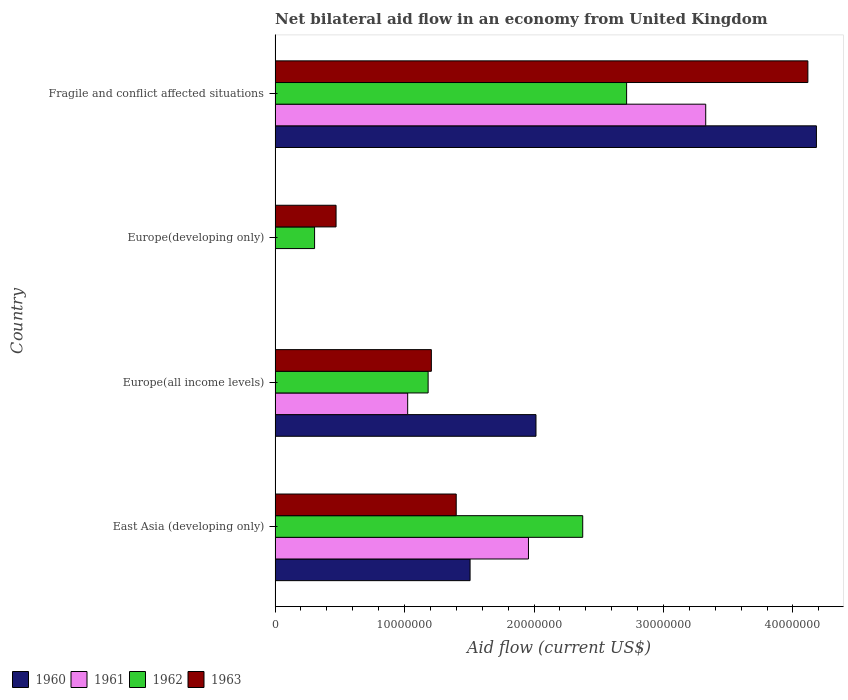How many different coloured bars are there?
Your answer should be compact. 4. How many bars are there on the 1st tick from the bottom?
Keep it short and to the point. 4. What is the label of the 1st group of bars from the top?
Ensure brevity in your answer.  Fragile and conflict affected situations. In how many cases, is the number of bars for a given country not equal to the number of legend labels?
Your response must be concise. 1. What is the net bilateral aid flow in 1962 in Europe(developing only)?
Keep it short and to the point. 3.05e+06. Across all countries, what is the maximum net bilateral aid flow in 1962?
Offer a very short reply. 2.72e+07. Across all countries, what is the minimum net bilateral aid flow in 1963?
Give a very brief answer. 4.71e+06. In which country was the net bilateral aid flow in 1961 maximum?
Make the answer very short. Fragile and conflict affected situations. What is the total net bilateral aid flow in 1962 in the graph?
Your answer should be compact. 6.58e+07. What is the difference between the net bilateral aid flow in 1963 in East Asia (developing only) and that in Fragile and conflict affected situations?
Your answer should be compact. -2.72e+07. What is the difference between the net bilateral aid flow in 1960 in Europe(developing only) and the net bilateral aid flow in 1961 in Europe(all income levels)?
Offer a terse response. -1.02e+07. What is the average net bilateral aid flow in 1962 per country?
Provide a succinct answer. 1.64e+07. What is the difference between the net bilateral aid flow in 1963 and net bilateral aid flow in 1961 in East Asia (developing only)?
Your answer should be compact. -5.58e+06. In how many countries, is the net bilateral aid flow in 1961 greater than 10000000 US$?
Offer a very short reply. 3. What is the ratio of the net bilateral aid flow in 1962 in East Asia (developing only) to that in Europe(all income levels)?
Offer a very short reply. 2.01. Is the net bilateral aid flow in 1963 in East Asia (developing only) less than that in Fragile and conflict affected situations?
Keep it short and to the point. Yes. What is the difference between the highest and the second highest net bilateral aid flow in 1962?
Make the answer very short. 3.39e+06. What is the difference between the highest and the lowest net bilateral aid flow in 1963?
Ensure brevity in your answer.  3.64e+07. Is the sum of the net bilateral aid flow in 1962 in East Asia (developing only) and Europe(all income levels) greater than the maximum net bilateral aid flow in 1963 across all countries?
Ensure brevity in your answer.  No. Is it the case that in every country, the sum of the net bilateral aid flow in 1960 and net bilateral aid flow in 1963 is greater than the sum of net bilateral aid flow in 1962 and net bilateral aid flow in 1961?
Provide a succinct answer. No. Is it the case that in every country, the sum of the net bilateral aid flow in 1963 and net bilateral aid flow in 1960 is greater than the net bilateral aid flow in 1962?
Your response must be concise. Yes. How many countries are there in the graph?
Keep it short and to the point. 4. What is the title of the graph?
Offer a very short reply. Net bilateral aid flow in an economy from United Kingdom. Does "1964" appear as one of the legend labels in the graph?
Offer a terse response. No. What is the Aid flow (current US$) in 1960 in East Asia (developing only)?
Keep it short and to the point. 1.51e+07. What is the Aid flow (current US$) in 1961 in East Asia (developing only)?
Your answer should be compact. 1.96e+07. What is the Aid flow (current US$) of 1962 in East Asia (developing only)?
Your answer should be compact. 2.38e+07. What is the Aid flow (current US$) of 1963 in East Asia (developing only)?
Give a very brief answer. 1.40e+07. What is the Aid flow (current US$) in 1960 in Europe(all income levels)?
Provide a succinct answer. 2.02e+07. What is the Aid flow (current US$) in 1961 in Europe(all income levels)?
Offer a very short reply. 1.02e+07. What is the Aid flow (current US$) of 1962 in Europe(all income levels)?
Make the answer very short. 1.18e+07. What is the Aid flow (current US$) in 1963 in Europe(all income levels)?
Make the answer very short. 1.21e+07. What is the Aid flow (current US$) in 1961 in Europe(developing only)?
Provide a succinct answer. 0. What is the Aid flow (current US$) of 1962 in Europe(developing only)?
Your answer should be very brief. 3.05e+06. What is the Aid flow (current US$) in 1963 in Europe(developing only)?
Keep it short and to the point. 4.71e+06. What is the Aid flow (current US$) of 1960 in Fragile and conflict affected situations?
Your answer should be compact. 4.18e+07. What is the Aid flow (current US$) in 1961 in Fragile and conflict affected situations?
Your answer should be very brief. 3.33e+07. What is the Aid flow (current US$) in 1962 in Fragile and conflict affected situations?
Your answer should be compact. 2.72e+07. What is the Aid flow (current US$) in 1963 in Fragile and conflict affected situations?
Your answer should be very brief. 4.12e+07. Across all countries, what is the maximum Aid flow (current US$) in 1960?
Give a very brief answer. 4.18e+07. Across all countries, what is the maximum Aid flow (current US$) of 1961?
Keep it short and to the point. 3.33e+07. Across all countries, what is the maximum Aid flow (current US$) in 1962?
Make the answer very short. 2.72e+07. Across all countries, what is the maximum Aid flow (current US$) of 1963?
Offer a very short reply. 4.12e+07. Across all countries, what is the minimum Aid flow (current US$) of 1962?
Provide a short and direct response. 3.05e+06. Across all countries, what is the minimum Aid flow (current US$) of 1963?
Your answer should be very brief. 4.71e+06. What is the total Aid flow (current US$) of 1960 in the graph?
Provide a succinct answer. 7.70e+07. What is the total Aid flow (current US$) in 1961 in the graph?
Your answer should be very brief. 6.31e+07. What is the total Aid flow (current US$) of 1962 in the graph?
Your answer should be compact. 6.58e+07. What is the total Aid flow (current US$) of 1963 in the graph?
Provide a short and direct response. 7.19e+07. What is the difference between the Aid flow (current US$) in 1960 in East Asia (developing only) and that in Europe(all income levels)?
Keep it short and to the point. -5.09e+06. What is the difference between the Aid flow (current US$) of 1961 in East Asia (developing only) and that in Europe(all income levels)?
Ensure brevity in your answer.  9.33e+06. What is the difference between the Aid flow (current US$) of 1962 in East Asia (developing only) and that in Europe(all income levels)?
Provide a short and direct response. 1.19e+07. What is the difference between the Aid flow (current US$) in 1963 in East Asia (developing only) and that in Europe(all income levels)?
Give a very brief answer. 1.92e+06. What is the difference between the Aid flow (current US$) in 1962 in East Asia (developing only) and that in Europe(developing only)?
Keep it short and to the point. 2.07e+07. What is the difference between the Aid flow (current US$) in 1963 in East Asia (developing only) and that in Europe(developing only)?
Give a very brief answer. 9.28e+06. What is the difference between the Aid flow (current US$) in 1960 in East Asia (developing only) and that in Fragile and conflict affected situations?
Provide a short and direct response. -2.68e+07. What is the difference between the Aid flow (current US$) of 1961 in East Asia (developing only) and that in Fragile and conflict affected situations?
Your response must be concise. -1.37e+07. What is the difference between the Aid flow (current US$) in 1962 in East Asia (developing only) and that in Fragile and conflict affected situations?
Provide a succinct answer. -3.39e+06. What is the difference between the Aid flow (current US$) of 1963 in East Asia (developing only) and that in Fragile and conflict affected situations?
Make the answer very short. -2.72e+07. What is the difference between the Aid flow (current US$) of 1962 in Europe(all income levels) and that in Europe(developing only)?
Your response must be concise. 8.77e+06. What is the difference between the Aid flow (current US$) of 1963 in Europe(all income levels) and that in Europe(developing only)?
Your answer should be very brief. 7.36e+06. What is the difference between the Aid flow (current US$) of 1960 in Europe(all income levels) and that in Fragile and conflict affected situations?
Ensure brevity in your answer.  -2.17e+07. What is the difference between the Aid flow (current US$) of 1961 in Europe(all income levels) and that in Fragile and conflict affected situations?
Provide a short and direct response. -2.30e+07. What is the difference between the Aid flow (current US$) of 1962 in Europe(all income levels) and that in Fragile and conflict affected situations?
Give a very brief answer. -1.53e+07. What is the difference between the Aid flow (current US$) in 1963 in Europe(all income levels) and that in Fragile and conflict affected situations?
Make the answer very short. -2.91e+07. What is the difference between the Aid flow (current US$) of 1962 in Europe(developing only) and that in Fragile and conflict affected situations?
Ensure brevity in your answer.  -2.41e+07. What is the difference between the Aid flow (current US$) of 1963 in Europe(developing only) and that in Fragile and conflict affected situations?
Provide a short and direct response. -3.64e+07. What is the difference between the Aid flow (current US$) of 1960 in East Asia (developing only) and the Aid flow (current US$) of 1961 in Europe(all income levels)?
Give a very brief answer. 4.82e+06. What is the difference between the Aid flow (current US$) in 1960 in East Asia (developing only) and the Aid flow (current US$) in 1962 in Europe(all income levels)?
Offer a terse response. 3.24e+06. What is the difference between the Aid flow (current US$) in 1960 in East Asia (developing only) and the Aid flow (current US$) in 1963 in Europe(all income levels)?
Give a very brief answer. 2.99e+06. What is the difference between the Aid flow (current US$) in 1961 in East Asia (developing only) and the Aid flow (current US$) in 1962 in Europe(all income levels)?
Provide a short and direct response. 7.75e+06. What is the difference between the Aid flow (current US$) in 1961 in East Asia (developing only) and the Aid flow (current US$) in 1963 in Europe(all income levels)?
Offer a very short reply. 7.50e+06. What is the difference between the Aid flow (current US$) in 1962 in East Asia (developing only) and the Aid flow (current US$) in 1963 in Europe(all income levels)?
Provide a short and direct response. 1.17e+07. What is the difference between the Aid flow (current US$) of 1960 in East Asia (developing only) and the Aid flow (current US$) of 1962 in Europe(developing only)?
Give a very brief answer. 1.20e+07. What is the difference between the Aid flow (current US$) in 1960 in East Asia (developing only) and the Aid flow (current US$) in 1963 in Europe(developing only)?
Your answer should be very brief. 1.04e+07. What is the difference between the Aid flow (current US$) in 1961 in East Asia (developing only) and the Aid flow (current US$) in 1962 in Europe(developing only)?
Provide a succinct answer. 1.65e+07. What is the difference between the Aid flow (current US$) in 1961 in East Asia (developing only) and the Aid flow (current US$) in 1963 in Europe(developing only)?
Provide a succinct answer. 1.49e+07. What is the difference between the Aid flow (current US$) of 1962 in East Asia (developing only) and the Aid flow (current US$) of 1963 in Europe(developing only)?
Make the answer very short. 1.90e+07. What is the difference between the Aid flow (current US$) in 1960 in East Asia (developing only) and the Aid flow (current US$) in 1961 in Fragile and conflict affected situations?
Your response must be concise. -1.82e+07. What is the difference between the Aid flow (current US$) in 1960 in East Asia (developing only) and the Aid flow (current US$) in 1962 in Fragile and conflict affected situations?
Offer a very short reply. -1.21e+07. What is the difference between the Aid flow (current US$) in 1960 in East Asia (developing only) and the Aid flow (current US$) in 1963 in Fragile and conflict affected situations?
Make the answer very short. -2.61e+07. What is the difference between the Aid flow (current US$) of 1961 in East Asia (developing only) and the Aid flow (current US$) of 1962 in Fragile and conflict affected situations?
Offer a very short reply. -7.58e+06. What is the difference between the Aid flow (current US$) in 1961 in East Asia (developing only) and the Aid flow (current US$) in 1963 in Fragile and conflict affected situations?
Your answer should be compact. -2.16e+07. What is the difference between the Aid flow (current US$) of 1962 in East Asia (developing only) and the Aid flow (current US$) of 1963 in Fragile and conflict affected situations?
Provide a succinct answer. -1.74e+07. What is the difference between the Aid flow (current US$) of 1960 in Europe(all income levels) and the Aid flow (current US$) of 1962 in Europe(developing only)?
Offer a terse response. 1.71e+07. What is the difference between the Aid flow (current US$) of 1960 in Europe(all income levels) and the Aid flow (current US$) of 1963 in Europe(developing only)?
Your response must be concise. 1.54e+07. What is the difference between the Aid flow (current US$) in 1961 in Europe(all income levels) and the Aid flow (current US$) in 1962 in Europe(developing only)?
Give a very brief answer. 7.19e+06. What is the difference between the Aid flow (current US$) in 1961 in Europe(all income levels) and the Aid flow (current US$) in 1963 in Europe(developing only)?
Offer a very short reply. 5.53e+06. What is the difference between the Aid flow (current US$) of 1962 in Europe(all income levels) and the Aid flow (current US$) of 1963 in Europe(developing only)?
Provide a succinct answer. 7.11e+06. What is the difference between the Aid flow (current US$) of 1960 in Europe(all income levels) and the Aid flow (current US$) of 1961 in Fragile and conflict affected situations?
Offer a very short reply. -1.31e+07. What is the difference between the Aid flow (current US$) of 1960 in Europe(all income levels) and the Aid flow (current US$) of 1962 in Fragile and conflict affected situations?
Your answer should be compact. -7.00e+06. What is the difference between the Aid flow (current US$) in 1960 in Europe(all income levels) and the Aid flow (current US$) in 1963 in Fragile and conflict affected situations?
Your response must be concise. -2.10e+07. What is the difference between the Aid flow (current US$) of 1961 in Europe(all income levels) and the Aid flow (current US$) of 1962 in Fragile and conflict affected situations?
Offer a very short reply. -1.69e+07. What is the difference between the Aid flow (current US$) of 1961 in Europe(all income levels) and the Aid flow (current US$) of 1963 in Fragile and conflict affected situations?
Your response must be concise. -3.09e+07. What is the difference between the Aid flow (current US$) of 1962 in Europe(all income levels) and the Aid flow (current US$) of 1963 in Fragile and conflict affected situations?
Your answer should be very brief. -2.93e+07. What is the difference between the Aid flow (current US$) in 1962 in Europe(developing only) and the Aid flow (current US$) in 1963 in Fragile and conflict affected situations?
Provide a short and direct response. -3.81e+07. What is the average Aid flow (current US$) of 1960 per country?
Your response must be concise. 1.93e+07. What is the average Aid flow (current US$) in 1961 per country?
Offer a terse response. 1.58e+07. What is the average Aid flow (current US$) in 1962 per country?
Give a very brief answer. 1.64e+07. What is the average Aid flow (current US$) in 1963 per country?
Keep it short and to the point. 1.80e+07. What is the difference between the Aid flow (current US$) in 1960 and Aid flow (current US$) in 1961 in East Asia (developing only)?
Offer a terse response. -4.51e+06. What is the difference between the Aid flow (current US$) of 1960 and Aid flow (current US$) of 1962 in East Asia (developing only)?
Provide a short and direct response. -8.70e+06. What is the difference between the Aid flow (current US$) of 1960 and Aid flow (current US$) of 1963 in East Asia (developing only)?
Offer a very short reply. 1.07e+06. What is the difference between the Aid flow (current US$) in 1961 and Aid flow (current US$) in 1962 in East Asia (developing only)?
Give a very brief answer. -4.19e+06. What is the difference between the Aid flow (current US$) of 1961 and Aid flow (current US$) of 1963 in East Asia (developing only)?
Provide a short and direct response. 5.58e+06. What is the difference between the Aid flow (current US$) of 1962 and Aid flow (current US$) of 1963 in East Asia (developing only)?
Your response must be concise. 9.77e+06. What is the difference between the Aid flow (current US$) of 1960 and Aid flow (current US$) of 1961 in Europe(all income levels)?
Provide a short and direct response. 9.91e+06. What is the difference between the Aid flow (current US$) of 1960 and Aid flow (current US$) of 1962 in Europe(all income levels)?
Offer a terse response. 8.33e+06. What is the difference between the Aid flow (current US$) in 1960 and Aid flow (current US$) in 1963 in Europe(all income levels)?
Make the answer very short. 8.08e+06. What is the difference between the Aid flow (current US$) in 1961 and Aid flow (current US$) in 1962 in Europe(all income levels)?
Ensure brevity in your answer.  -1.58e+06. What is the difference between the Aid flow (current US$) in 1961 and Aid flow (current US$) in 1963 in Europe(all income levels)?
Offer a terse response. -1.83e+06. What is the difference between the Aid flow (current US$) in 1962 and Aid flow (current US$) in 1963 in Europe(developing only)?
Your answer should be very brief. -1.66e+06. What is the difference between the Aid flow (current US$) in 1960 and Aid flow (current US$) in 1961 in Fragile and conflict affected situations?
Offer a terse response. 8.55e+06. What is the difference between the Aid flow (current US$) of 1960 and Aid flow (current US$) of 1962 in Fragile and conflict affected situations?
Your answer should be compact. 1.47e+07. What is the difference between the Aid flow (current US$) in 1960 and Aid flow (current US$) in 1963 in Fragile and conflict affected situations?
Provide a succinct answer. 6.60e+05. What is the difference between the Aid flow (current US$) in 1961 and Aid flow (current US$) in 1962 in Fragile and conflict affected situations?
Keep it short and to the point. 6.11e+06. What is the difference between the Aid flow (current US$) in 1961 and Aid flow (current US$) in 1963 in Fragile and conflict affected situations?
Offer a terse response. -7.89e+06. What is the difference between the Aid flow (current US$) of 1962 and Aid flow (current US$) of 1963 in Fragile and conflict affected situations?
Your answer should be compact. -1.40e+07. What is the ratio of the Aid flow (current US$) in 1960 in East Asia (developing only) to that in Europe(all income levels)?
Give a very brief answer. 0.75. What is the ratio of the Aid flow (current US$) in 1961 in East Asia (developing only) to that in Europe(all income levels)?
Your response must be concise. 1.91. What is the ratio of the Aid flow (current US$) of 1962 in East Asia (developing only) to that in Europe(all income levels)?
Keep it short and to the point. 2.01. What is the ratio of the Aid flow (current US$) in 1963 in East Asia (developing only) to that in Europe(all income levels)?
Give a very brief answer. 1.16. What is the ratio of the Aid flow (current US$) in 1962 in East Asia (developing only) to that in Europe(developing only)?
Keep it short and to the point. 7.79. What is the ratio of the Aid flow (current US$) of 1963 in East Asia (developing only) to that in Europe(developing only)?
Your response must be concise. 2.97. What is the ratio of the Aid flow (current US$) in 1960 in East Asia (developing only) to that in Fragile and conflict affected situations?
Your answer should be very brief. 0.36. What is the ratio of the Aid flow (current US$) in 1961 in East Asia (developing only) to that in Fragile and conflict affected situations?
Offer a very short reply. 0.59. What is the ratio of the Aid flow (current US$) in 1962 in East Asia (developing only) to that in Fragile and conflict affected situations?
Your answer should be very brief. 0.88. What is the ratio of the Aid flow (current US$) of 1963 in East Asia (developing only) to that in Fragile and conflict affected situations?
Your answer should be very brief. 0.34. What is the ratio of the Aid flow (current US$) of 1962 in Europe(all income levels) to that in Europe(developing only)?
Keep it short and to the point. 3.88. What is the ratio of the Aid flow (current US$) in 1963 in Europe(all income levels) to that in Europe(developing only)?
Give a very brief answer. 2.56. What is the ratio of the Aid flow (current US$) of 1960 in Europe(all income levels) to that in Fragile and conflict affected situations?
Provide a succinct answer. 0.48. What is the ratio of the Aid flow (current US$) in 1961 in Europe(all income levels) to that in Fragile and conflict affected situations?
Give a very brief answer. 0.31. What is the ratio of the Aid flow (current US$) in 1962 in Europe(all income levels) to that in Fragile and conflict affected situations?
Ensure brevity in your answer.  0.44. What is the ratio of the Aid flow (current US$) of 1963 in Europe(all income levels) to that in Fragile and conflict affected situations?
Your response must be concise. 0.29. What is the ratio of the Aid flow (current US$) in 1962 in Europe(developing only) to that in Fragile and conflict affected situations?
Offer a terse response. 0.11. What is the ratio of the Aid flow (current US$) of 1963 in Europe(developing only) to that in Fragile and conflict affected situations?
Give a very brief answer. 0.11. What is the difference between the highest and the second highest Aid flow (current US$) in 1960?
Keep it short and to the point. 2.17e+07. What is the difference between the highest and the second highest Aid flow (current US$) in 1961?
Provide a short and direct response. 1.37e+07. What is the difference between the highest and the second highest Aid flow (current US$) in 1962?
Keep it short and to the point. 3.39e+06. What is the difference between the highest and the second highest Aid flow (current US$) in 1963?
Make the answer very short. 2.72e+07. What is the difference between the highest and the lowest Aid flow (current US$) in 1960?
Provide a succinct answer. 4.18e+07. What is the difference between the highest and the lowest Aid flow (current US$) of 1961?
Your response must be concise. 3.33e+07. What is the difference between the highest and the lowest Aid flow (current US$) in 1962?
Your response must be concise. 2.41e+07. What is the difference between the highest and the lowest Aid flow (current US$) in 1963?
Give a very brief answer. 3.64e+07. 